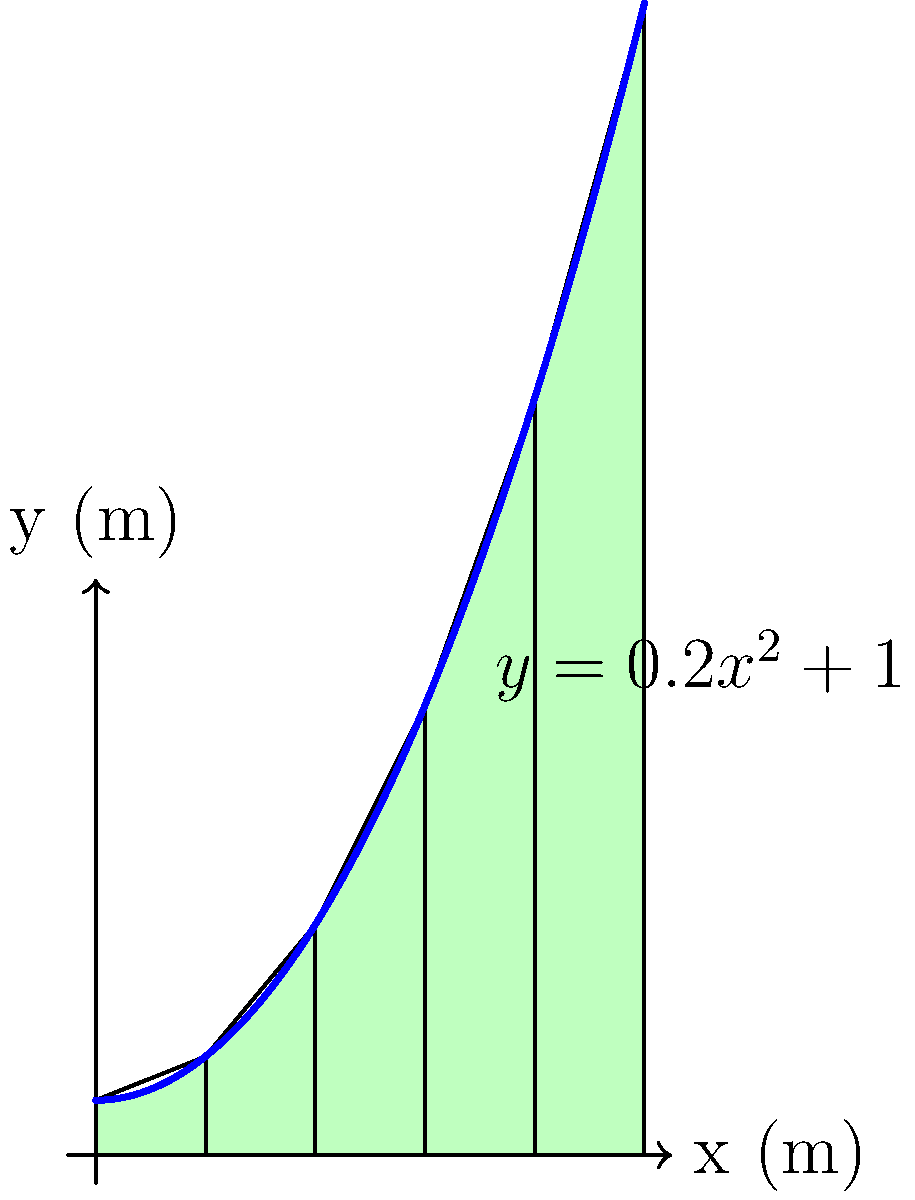A commercial property lot has an irregular shape that can be approximated by the function $y = 0.2x^2 + 1$, where $x$ and $y$ are measured in meters. The lot extends from $x = 0$ to $x = 10$ meters. Using the trapezoidal rule with 5 equal subdivisions, estimate the area of the lot in square meters. How might this information be useful in determining the property's value or potential development costs? To estimate the area using the trapezoidal rule with 5 subdivisions:

1) Divide the interval $[0, 10]$ into 5 equal parts. Each subinterval has width $\Delta x = \frac{10-0}{5} = 2$ meters.

2) Calculate $y$ values at the endpoints of each subinterval:
   $y_0 = f(0) = 1$
   $y_1 = f(2) = 0.2(2^2) + 1 = 1.8$
   $y_2 = f(4) = 0.2(4^2) + 1 = 4.2$
   $y_3 = f(6) = 0.2(6^2) + 1 = 8.2$
   $y_4 = f(8) = 0.2(8^2) + 1 = 13.8$
   $y_5 = f(10) = 0.2(10^2) + 1 = 21$

3) Apply the trapezoidal rule formula:
   Area $\approx \frac{\Delta x}{2}[y_0 + 2(y_1 + y_2 + y_3 + y_4) + y_5]$
   
   $= \frac{2}{2}[1 + 2(1.8 + 4.2 + 8.2 + 13.8) + 21]$
   
   $= 1[1 + 2(28) + 21]$
   
   $= 1[1 + 56 + 21]$
   
   $= 78$ square meters

This area estimation is crucial for:
1) Valuation: Property value often correlates with land area.
2) Development costs: Construction and materials costs typically scale with area.
3) Zoning compliance: Ensures the property meets local area requirements.
4) Financing: Lenders often consider property size in loan assessments.
5) Potential usage: Helps in planning building footprint and outdoor spaces.
Answer: 78 square meters 